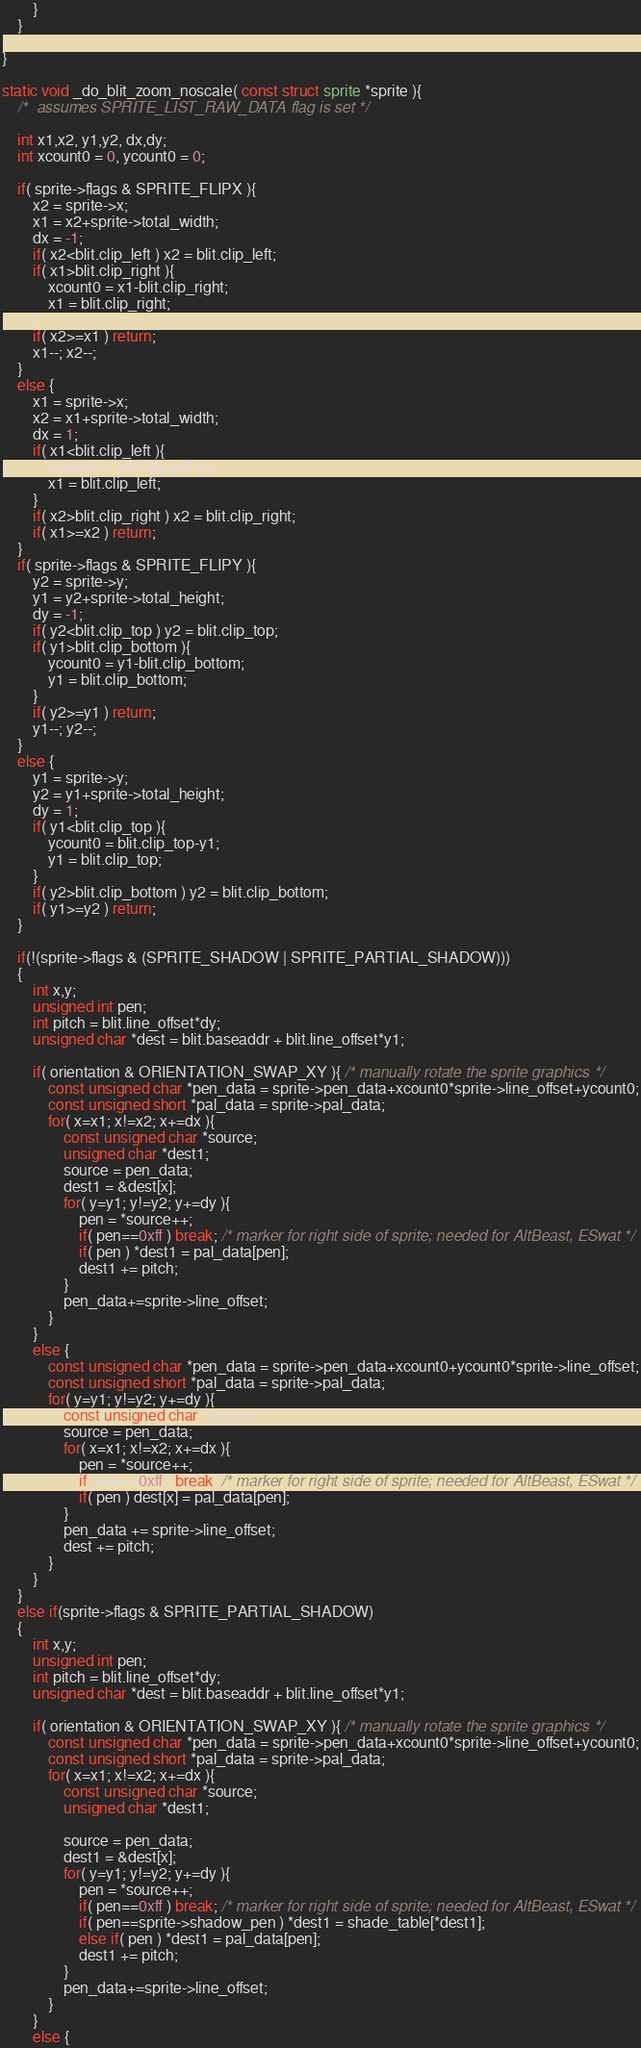Convert code to text. <code><loc_0><loc_0><loc_500><loc_500><_C++_>		}
	}

}

static void _do_blit_zoom_noscale( const struct sprite *sprite ){
	/*	assumes SPRITE_LIST_RAW_DATA flag is set */

	int x1,x2, y1,y2, dx,dy;
	int xcount0 = 0, ycount0 = 0;

	if( sprite->flags & SPRITE_FLIPX ){
		x2 = sprite->x;
		x1 = x2+sprite->total_width;
		dx = -1;
		if( x2<blit.clip_left ) x2 = blit.clip_left;
		if( x1>blit.clip_right ){
			xcount0 = x1-blit.clip_right;
			x1 = blit.clip_right;
		}
		if( x2>=x1 ) return;
		x1--; x2--;
	}
	else {
		x1 = sprite->x;
		x2 = x1+sprite->total_width;
		dx = 1;
		if( x1<blit.clip_left ){
			xcount0 = blit.clip_left-x1;
			x1 = blit.clip_left;
		}
		if( x2>blit.clip_right ) x2 = blit.clip_right;
		if( x1>=x2 ) return;
	}
	if( sprite->flags & SPRITE_FLIPY ){
		y2 = sprite->y;
		y1 = y2+sprite->total_height;
		dy = -1;
		if( y2<blit.clip_top ) y2 = blit.clip_top;
		if( y1>blit.clip_bottom ){
			ycount0 = y1-blit.clip_bottom;
			y1 = blit.clip_bottom;
		}
		if( y2>=y1 ) return;
		y1--; y2--;
	}
	else {
		y1 = sprite->y;
		y2 = y1+sprite->total_height;
		dy = 1;
		if( y1<blit.clip_top ){
			ycount0 = blit.clip_top-y1;
			y1 = blit.clip_top;
		}
		if( y2>blit.clip_bottom ) y2 = blit.clip_bottom;
		if( y1>=y2 ) return;
	}

	if(!(sprite->flags & (SPRITE_SHADOW | SPRITE_PARTIAL_SHADOW)))
	{
		int x,y;
		unsigned int pen;
		int pitch = blit.line_offset*dy;
		unsigned char *dest = blit.baseaddr + blit.line_offset*y1;

		if( orientation & ORIENTATION_SWAP_XY ){ /* manually rotate the sprite graphics */
    		const unsigned char *pen_data = sprite->pen_data+xcount0*sprite->line_offset+ycount0;
	    	const unsigned short *pal_data = sprite->pal_data;
			for( x=x1; x!=x2; x+=dx ){
				const unsigned char *source;
				unsigned char *dest1;
				source = pen_data;
				dest1 = &dest[x];
				for( y=y1; y!=y2; y+=dy ){
					pen = *source++;
					if( pen==0xff ) break; /* marker for right side of sprite; needed for AltBeast, ESwat */
                    if( pen ) *dest1 = pal_data[pen];
					dest1 += pitch;
				}
    			pen_data+=sprite->line_offset;
			}
		}
		else {
    		const unsigned char *pen_data = sprite->pen_data+xcount0+ycount0*sprite->line_offset;
	    	const unsigned short *pal_data = sprite->pal_data;
			for( y=y1; y!=y2; y+=dy ){
				const unsigned char *source;
				source = pen_data;
				for( x=x1; x!=x2; x+=dx ){
					pen = *source++;
					if( pen==0xff ) break; /* marker for right side of sprite; needed for AltBeast, ESwat */
                    if( pen ) dest[x] = pal_data[pen];
				}
				pen_data += sprite->line_offset;
				dest += pitch;
			}
		}
	}
	else if(sprite->flags & SPRITE_PARTIAL_SHADOW)
	{
		int x,y;
		unsigned int pen;
		int pitch = blit.line_offset*dy;
		unsigned char *dest = blit.baseaddr + blit.line_offset*y1;

		if( orientation & ORIENTATION_SWAP_XY ){ /* manually rotate the sprite graphics */
    		const unsigned char *pen_data = sprite->pen_data+xcount0*sprite->line_offset+ycount0;
	    	const unsigned short *pal_data = sprite->pal_data;
			for( x=x1; x!=x2; x+=dx ){
				const unsigned char *source;
				unsigned char *dest1;

				source = pen_data;
				dest1 = &dest[x];
				for( y=y1; y!=y2; y+=dy ){
					pen = *source++;
					if( pen==0xff ) break; /* marker for right side of sprite; needed for AltBeast, ESwat */
					if( pen==sprite->shadow_pen ) *dest1 = shade_table[*dest1];
					else if( pen ) *dest1 = pal_data[pen];
					dest1 += pitch;
				}
				pen_data+=sprite->line_offset;
			}
		}
		else {</code> 